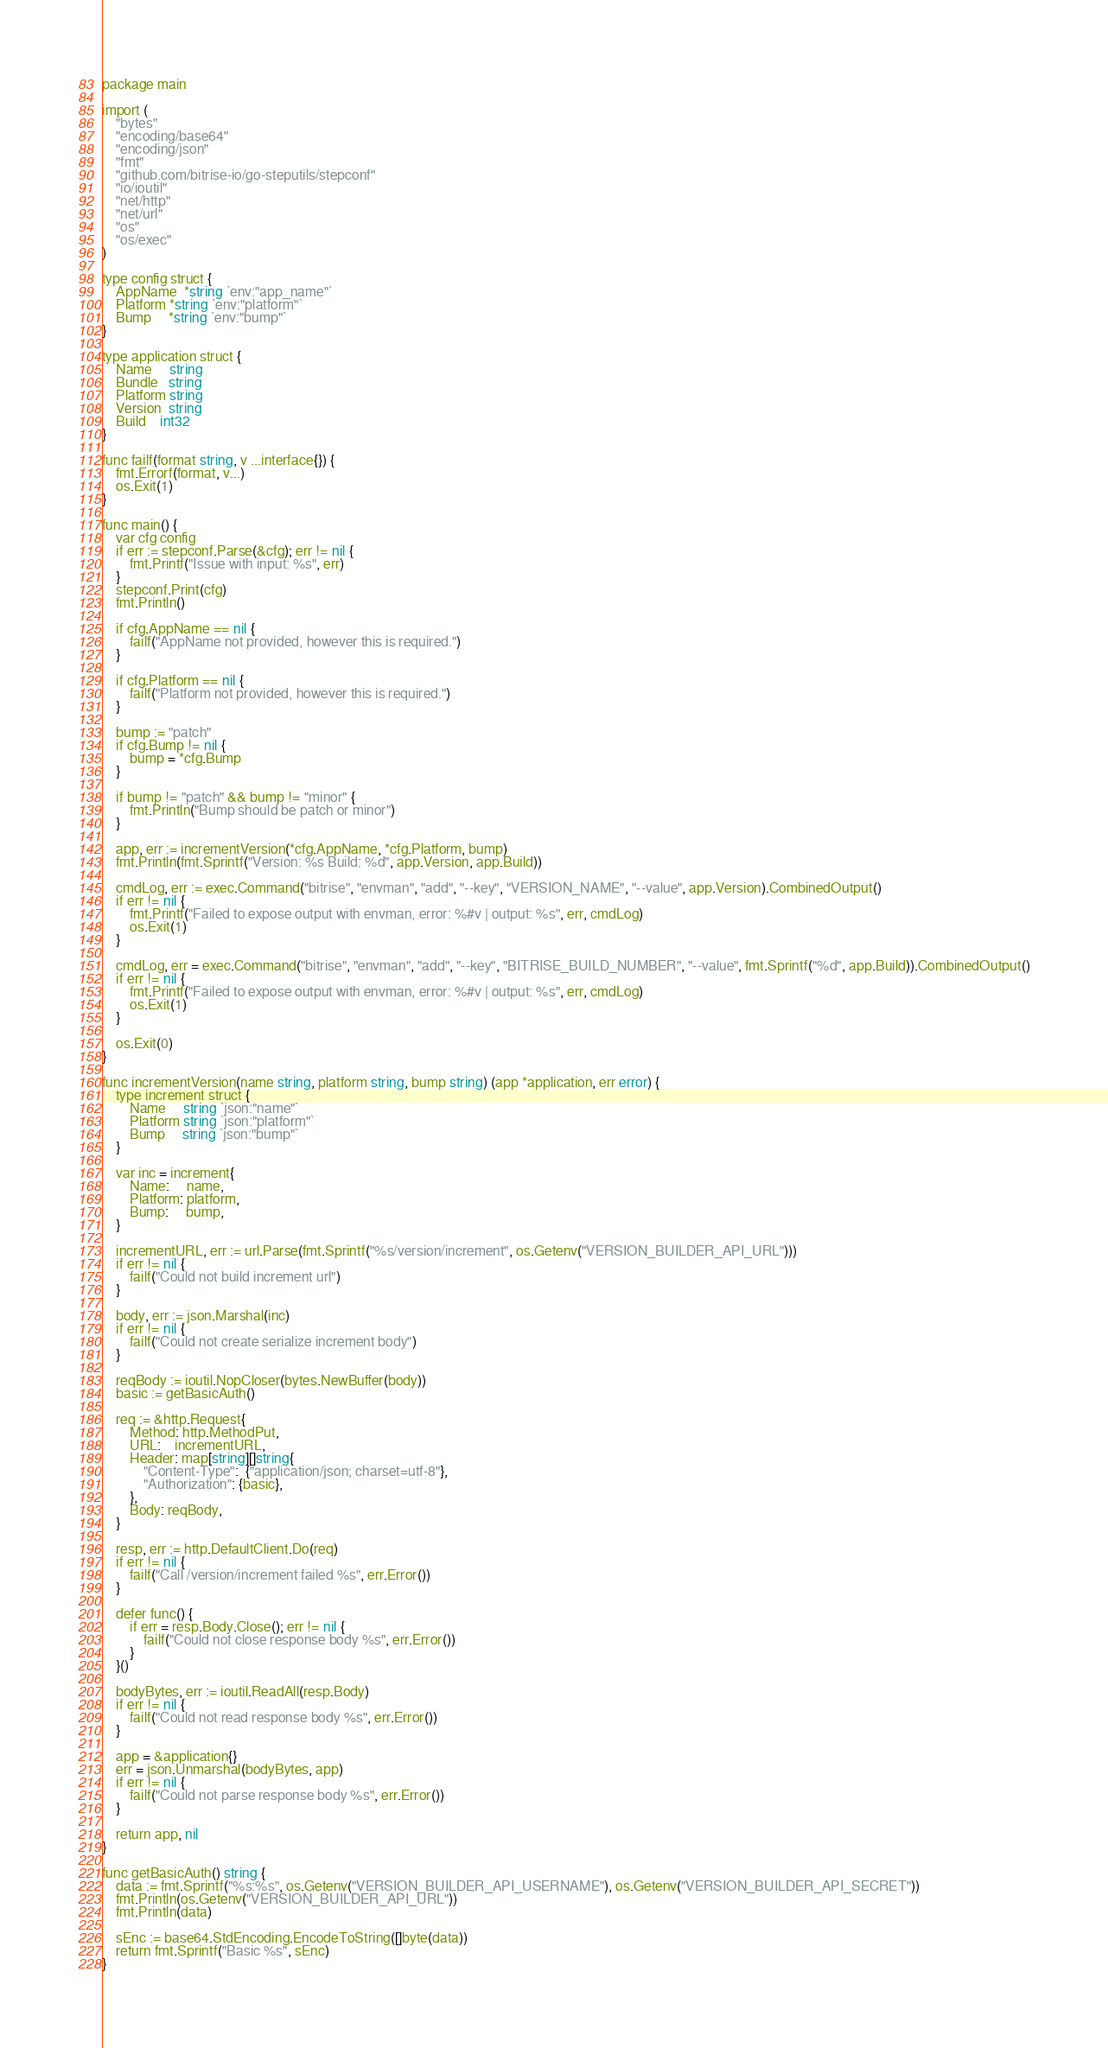Convert code to text. <code><loc_0><loc_0><loc_500><loc_500><_Go_>package main

import (
	"bytes"
	"encoding/base64"
	"encoding/json"
	"fmt"
	"github.com/bitrise-io/go-steputils/stepconf"
	"io/ioutil"
	"net/http"
	"net/url"
	"os"
	"os/exec"
)

type config struct {
	AppName  *string `env:"app_name"`
	Platform *string `env:"platform"`
	Bump     *string `env:"bump"`
}

type application struct {
	Name     string
	Bundle   string
	Platform string
	Version  string
	Build    int32
}

func failf(format string, v ...interface{}) {
	fmt.Errorf(format, v...)
	os.Exit(1)
}

func main() {
	var cfg config
	if err := stepconf.Parse(&cfg); err != nil {
		fmt.Printf("Issue with input: %s", err)
	}
	stepconf.Print(cfg)
	fmt.Println()

	if cfg.AppName == nil {
		failf("AppName not provided, however this is required.")
	}

	if cfg.Platform == nil {
		failf("Platform not provided, however this is required.")
	}

	bump := "patch"
	if cfg.Bump != nil {
		bump = *cfg.Bump
	}

	if bump != "patch" && bump != "minor" {
		fmt.Println("Bump should be patch or minor")
	}

	app, err := incrementVersion(*cfg.AppName, *cfg.Platform, bump)
	fmt.Println(fmt.Sprintf("Version: %s Build: %d", app.Version, app.Build))

	cmdLog, err := exec.Command("bitrise", "envman", "add", "--key", "VERSION_NAME", "--value", app.Version).CombinedOutput()
	if err != nil {
		fmt.Printf("Failed to expose output with envman, error: %#v | output: %s", err, cmdLog)
		os.Exit(1)
	}

	cmdLog, err = exec.Command("bitrise", "envman", "add", "--key", "BITRISE_BUILD_NUMBER", "--value", fmt.Sprintf("%d", app.Build)).CombinedOutput()
	if err != nil {
		fmt.Printf("Failed to expose output with envman, error: %#v | output: %s", err, cmdLog)
		os.Exit(1)
	}

	os.Exit(0)
}

func incrementVersion(name string, platform string, bump string) (app *application, err error) {
	type increment struct {
		Name     string `json:"name"`
		Platform string `json:"platform"`
		Bump     string `json:"bump"`
	}

	var inc = increment{
		Name:     name,
		Platform: platform,
		Bump:     bump,
	}

	incrementURL, err := url.Parse(fmt.Sprintf("%s/version/increment", os.Getenv("VERSION_BUILDER_API_URL")))
	if err != nil {
		failf("Could not build increment url")
	}

	body, err := json.Marshal(inc)
	if err != nil {
		failf("Could not create serialize increment body")
	}

	reqBody := ioutil.NopCloser(bytes.NewBuffer(body))
	basic := getBasicAuth()

	req := &http.Request{
		Method: http.MethodPut,
		URL:    incrementURL,
		Header: map[string][]string{
			"Content-Type":  {"application/json; charset=utf-8"},
			"Authorization": {basic},
		},
		Body: reqBody,
	}

	resp, err := http.DefaultClient.Do(req)
	if err != nil {
		failf("Call /version/increment failed %s", err.Error())
	}

	defer func() {
		if err = resp.Body.Close(); err != nil {
			failf("Could not close response body %s", err.Error())
		}
	}()

	bodyBytes, err := ioutil.ReadAll(resp.Body)
	if err != nil {
		failf("Could not read response body %s", err.Error())
	}

	app = &application{}
	err = json.Unmarshal(bodyBytes, app)
	if err != nil {
		failf("Could not parse response body %s", err.Error())
	}

	return app, nil
}

func getBasicAuth() string {
	data := fmt.Sprintf("%s:%s", os.Getenv("VERSION_BUILDER_API_USERNAME"), os.Getenv("VERSION_BUILDER_API_SECRET"))
	fmt.Println(os.Getenv("VERSION_BUILDER_API_URL"))
	fmt.Println(data)

	sEnc := base64.StdEncoding.EncodeToString([]byte(data))
	return fmt.Sprintf("Basic %s", sEnc)
}
</code> 